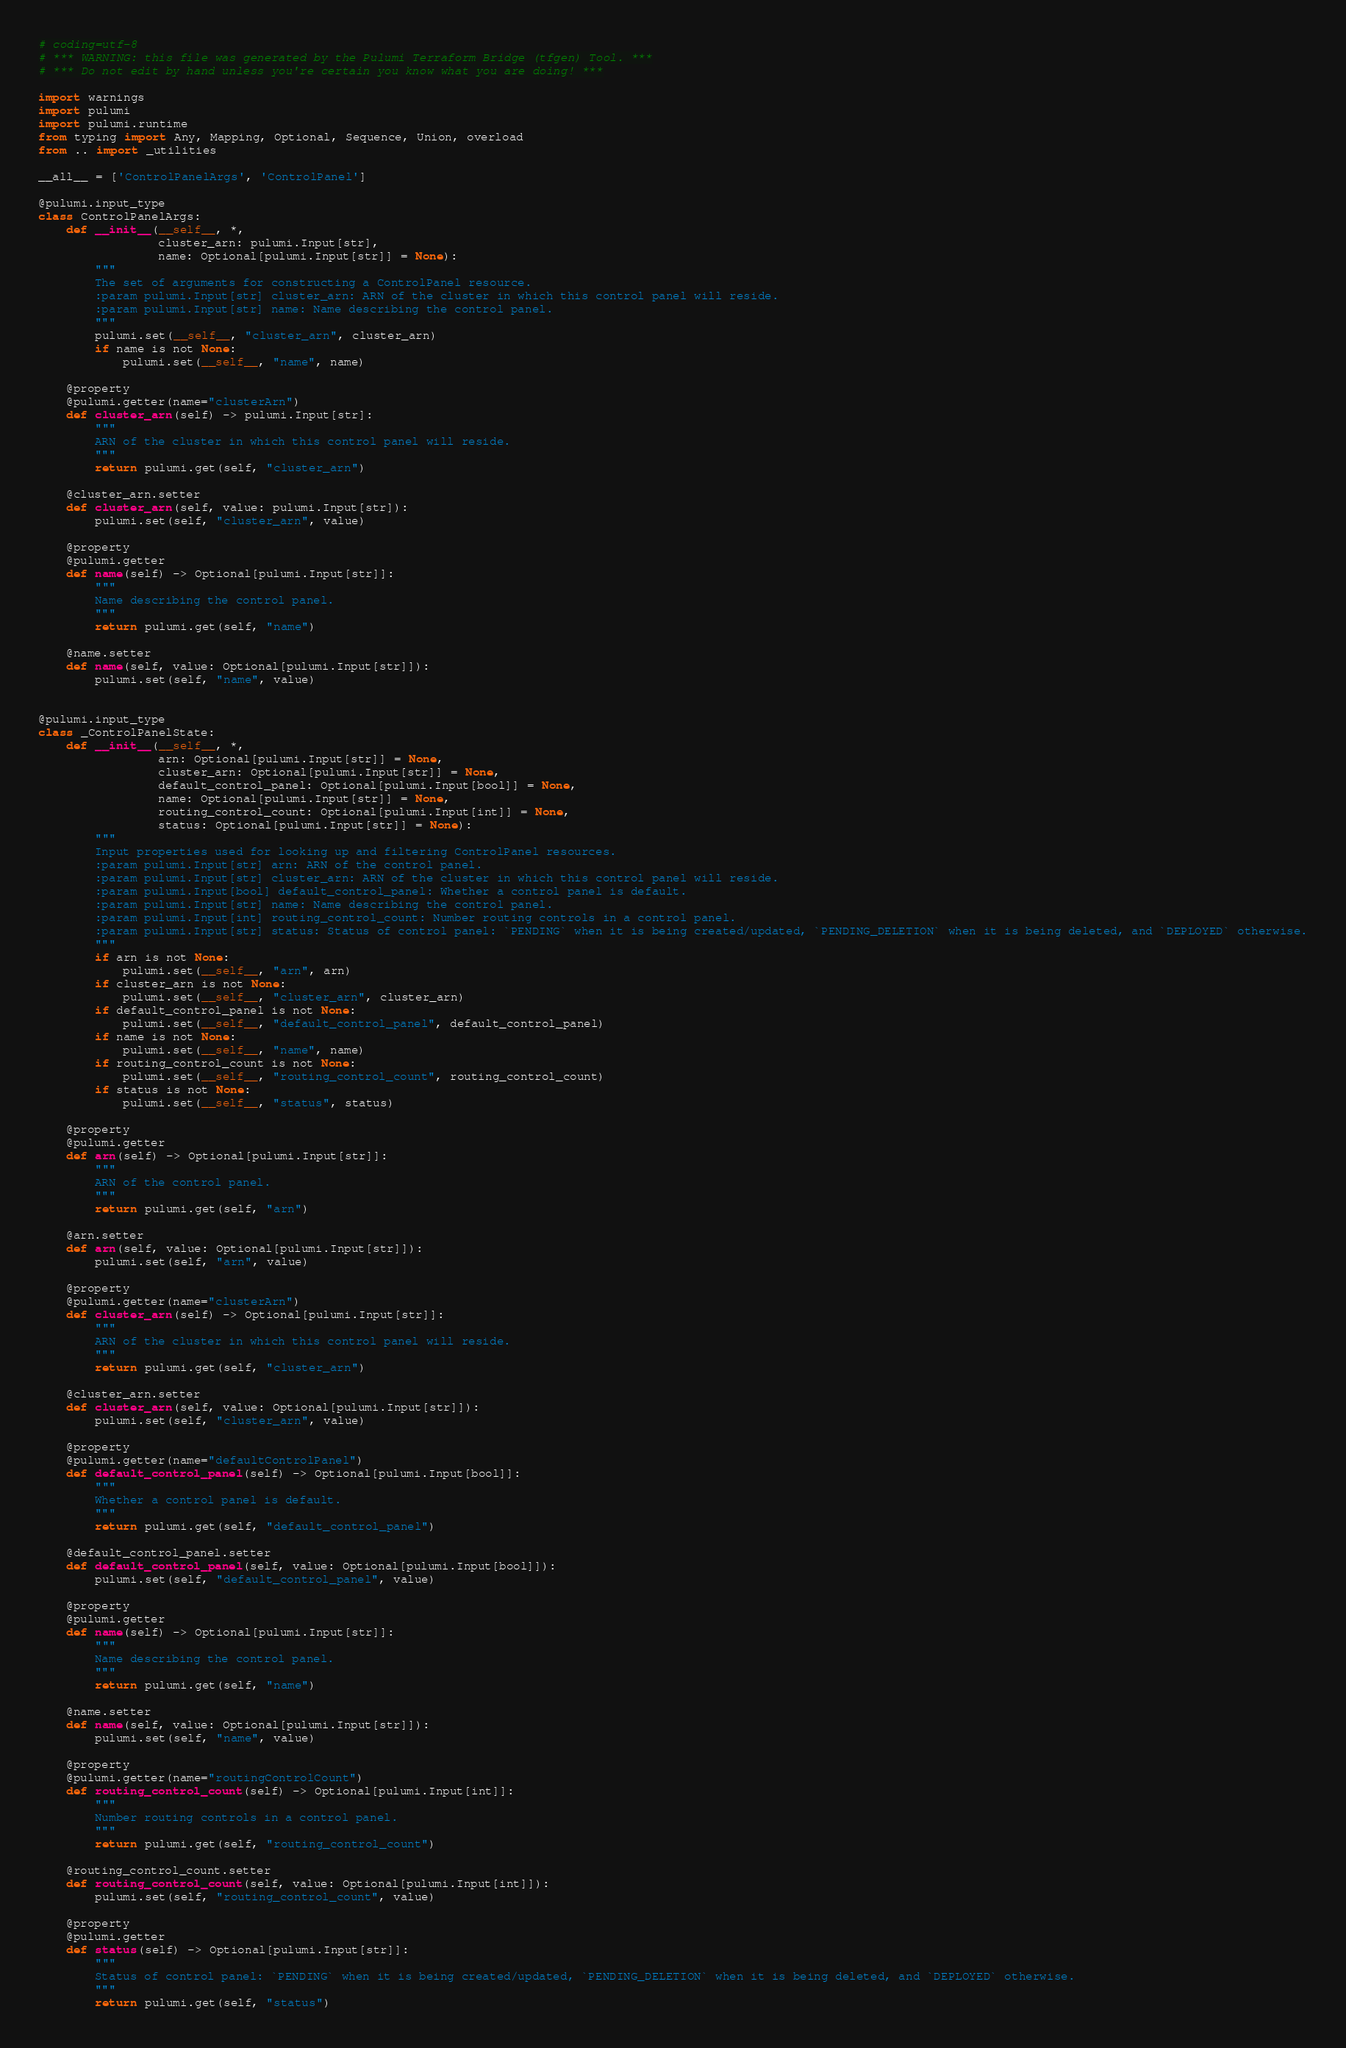<code> <loc_0><loc_0><loc_500><loc_500><_Python_># coding=utf-8
# *** WARNING: this file was generated by the Pulumi Terraform Bridge (tfgen) Tool. ***
# *** Do not edit by hand unless you're certain you know what you are doing! ***

import warnings
import pulumi
import pulumi.runtime
from typing import Any, Mapping, Optional, Sequence, Union, overload
from .. import _utilities

__all__ = ['ControlPanelArgs', 'ControlPanel']

@pulumi.input_type
class ControlPanelArgs:
    def __init__(__self__, *,
                 cluster_arn: pulumi.Input[str],
                 name: Optional[pulumi.Input[str]] = None):
        """
        The set of arguments for constructing a ControlPanel resource.
        :param pulumi.Input[str] cluster_arn: ARN of the cluster in which this control panel will reside.
        :param pulumi.Input[str] name: Name describing the control panel.
        """
        pulumi.set(__self__, "cluster_arn", cluster_arn)
        if name is not None:
            pulumi.set(__self__, "name", name)

    @property
    @pulumi.getter(name="clusterArn")
    def cluster_arn(self) -> pulumi.Input[str]:
        """
        ARN of the cluster in which this control panel will reside.
        """
        return pulumi.get(self, "cluster_arn")

    @cluster_arn.setter
    def cluster_arn(self, value: pulumi.Input[str]):
        pulumi.set(self, "cluster_arn", value)

    @property
    @pulumi.getter
    def name(self) -> Optional[pulumi.Input[str]]:
        """
        Name describing the control panel.
        """
        return pulumi.get(self, "name")

    @name.setter
    def name(self, value: Optional[pulumi.Input[str]]):
        pulumi.set(self, "name", value)


@pulumi.input_type
class _ControlPanelState:
    def __init__(__self__, *,
                 arn: Optional[pulumi.Input[str]] = None,
                 cluster_arn: Optional[pulumi.Input[str]] = None,
                 default_control_panel: Optional[pulumi.Input[bool]] = None,
                 name: Optional[pulumi.Input[str]] = None,
                 routing_control_count: Optional[pulumi.Input[int]] = None,
                 status: Optional[pulumi.Input[str]] = None):
        """
        Input properties used for looking up and filtering ControlPanel resources.
        :param pulumi.Input[str] arn: ARN of the control panel.
        :param pulumi.Input[str] cluster_arn: ARN of the cluster in which this control panel will reside.
        :param pulumi.Input[bool] default_control_panel: Whether a control panel is default.
        :param pulumi.Input[str] name: Name describing the control panel.
        :param pulumi.Input[int] routing_control_count: Number routing controls in a control panel.
        :param pulumi.Input[str] status: Status of control panel: `PENDING` when it is being created/updated, `PENDING_DELETION` when it is being deleted, and `DEPLOYED` otherwise.
        """
        if arn is not None:
            pulumi.set(__self__, "arn", arn)
        if cluster_arn is not None:
            pulumi.set(__self__, "cluster_arn", cluster_arn)
        if default_control_panel is not None:
            pulumi.set(__self__, "default_control_panel", default_control_panel)
        if name is not None:
            pulumi.set(__self__, "name", name)
        if routing_control_count is not None:
            pulumi.set(__self__, "routing_control_count", routing_control_count)
        if status is not None:
            pulumi.set(__self__, "status", status)

    @property
    @pulumi.getter
    def arn(self) -> Optional[pulumi.Input[str]]:
        """
        ARN of the control panel.
        """
        return pulumi.get(self, "arn")

    @arn.setter
    def arn(self, value: Optional[pulumi.Input[str]]):
        pulumi.set(self, "arn", value)

    @property
    @pulumi.getter(name="clusterArn")
    def cluster_arn(self) -> Optional[pulumi.Input[str]]:
        """
        ARN of the cluster in which this control panel will reside.
        """
        return pulumi.get(self, "cluster_arn")

    @cluster_arn.setter
    def cluster_arn(self, value: Optional[pulumi.Input[str]]):
        pulumi.set(self, "cluster_arn", value)

    @property
    @pulumi.getter(name="defaultControlPanel")
    def default_control_panel(self) -> Optional[pulumi.Input[bool]]:
        """
        Whether a control panel is default.
        """
        return pulumi.get(self, "default_control_panel")

    @default_control_panel.setter
    def default_control_panel(self, value: Optional[pulumi.Input[bool]]):
        pulumi.set(self, "default_control_panel", value)

    @property
    @pulumi.getter
    def name(self) -> Optional[pulumi.Input[str]]:
        """
        Name describing the control panel.
        """
        return pulumi.get(self, "name")

    @name.setter
    def name(self, value: Optional[pulumi.Input[str]]):
        pulumi.set(self, "name", value)

    @property
    @pulumi.getter(name="routingControlCount")
    def routing_control_count(self) -> Optional[pulumi.Input[int]]:
        """
        Number routing controls in a control panel.
        """
        return pulumi.get(self, "routing_control_count")

    @routing_control_count.setter
    def routing_control_count(self, value: Optional[pulumi.Input[int]]):
        pulumi.set(self, "routing_control_count", value)

    @property
    @pulumi.getter
    def status(self) -> Optional[pulumi.Input[str]]:
        """
        Status of control panel: `PENDING` when it is being created/updated, `PENDING_DELETION` when it is being deleted, and `DEPLOYED` otherwise.
        """
        return pulumi.get(self, "status")
</code> 